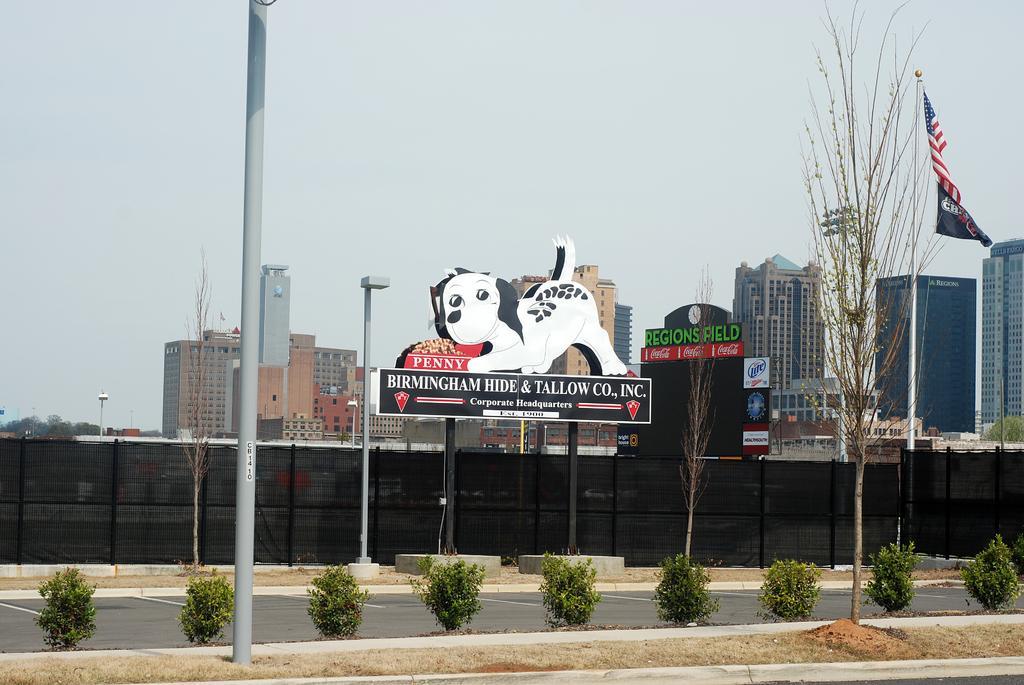Could you give a brief overview of what you see in this image? In front of the image there is a pole and also there is a tree. Behind them there are small plants and also there is a road. Behind the road on the ground there is a pole and a name board with names and an image on it. Behind them there is fencing. Behind the fencing there is a building and there are poles with flags and also there are trees. At the top of the image there is sky 